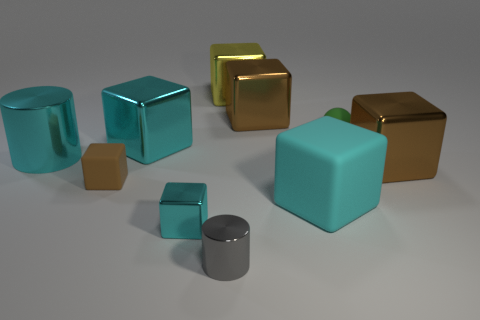Subtract all brown cubes. How many were subtracted if there are1brown cubes left? 2 Subtract all brown blocks. How many blocks are left? 4 Subtract all cyan cylinders. How many cylinders are left? 1 Subtract 4 cubes. How many cubes are left? 3 Subtract all spheres. How many objects are left? 9 Add 2 tiny metallic cylinders. How many tiny metallic cylinders are left? 3 Add 3 small rubber spheres. How many small rubber spheres exist? 4 Subtract 0 red blocks. How many objects are left? 10 Subtract all brown blocks. Subtract all blue spheres. How many blocks are left? 4 Subtract all red cylinders. How many cyan blocks are left? 3 